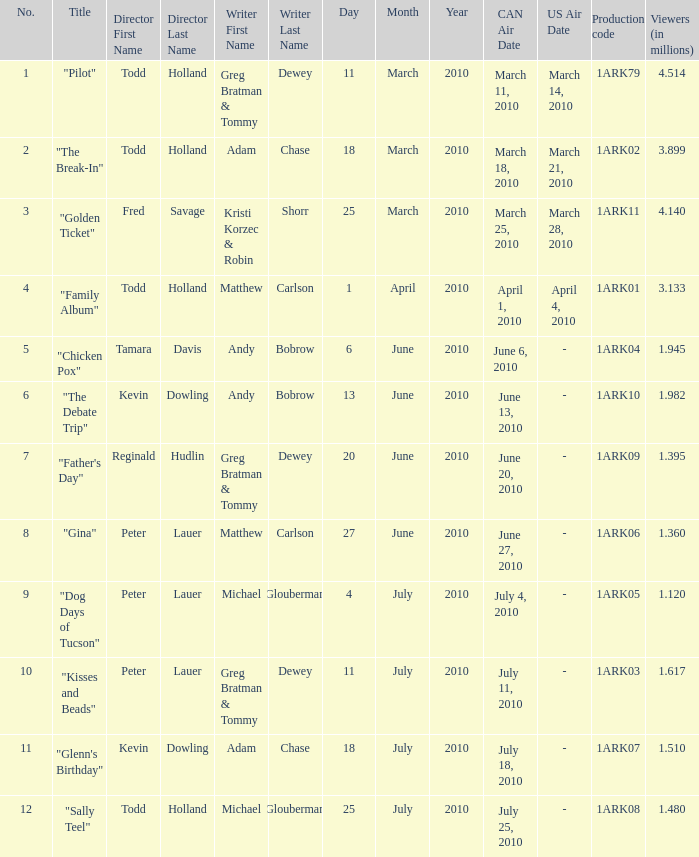How many millions of people viewed "Father's Day"? 1.395. 